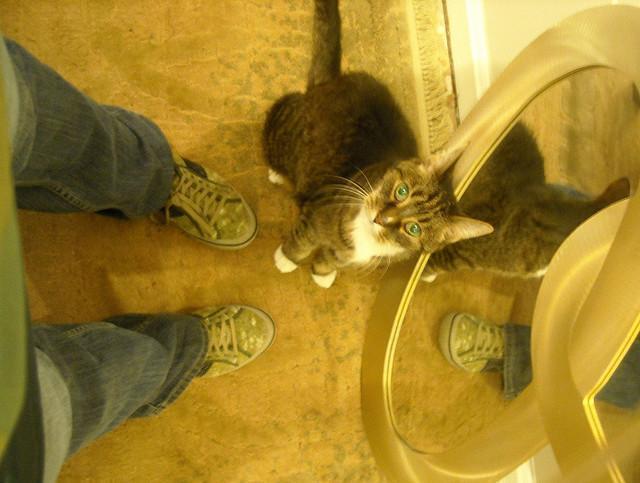How many cats are there?
Give a very brief answer. 1. How many dogs are playing here?
Give a very brief answer. 0. 